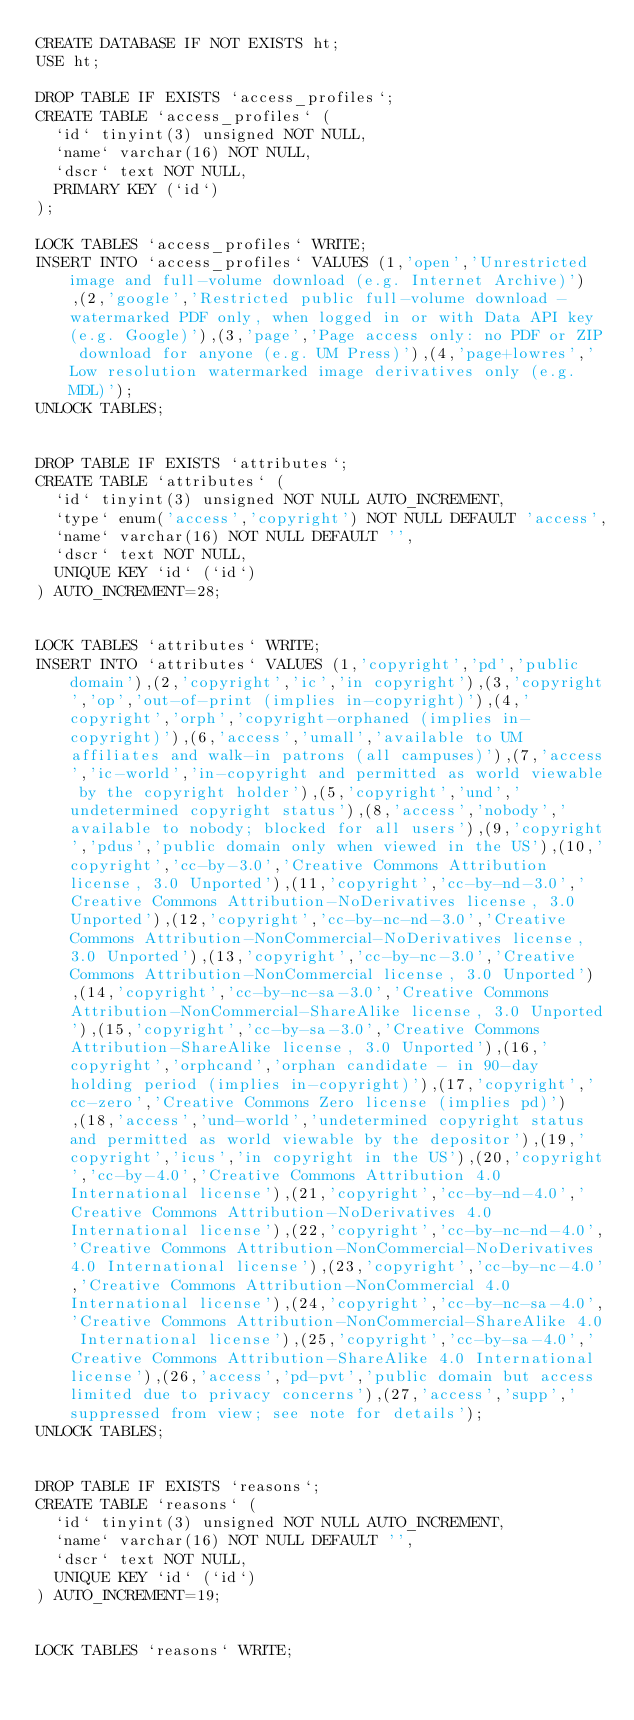Convert code to text. <code><loc_0><loc_0><loc_500><loc_500><_SQL_>CREATE DATABASE IF NOT EXISTS ht;
USE ht;

DROP TABLE IF EXISTS `access_profiles`;
CREATE TABLE `access_profiles` (
  `id` tinyint(3) unsigned NOT NULL,
  `name` varchar(16) NOT NULL,
  `dscr` text NOT NULL,
  PRIMARY KEY (`id`)
);

LOCK TABLES `access_profiles` WRITE;
INSERT INTO `access_profiles` VALUES (1,'open','Unrestricted image and full-volume download (e.g. Internet Archive)'),(2,'google','Restricted public full-volume download - watermarked PDF only, when logged in or with Data API key (e.g. Google)'),(3,'page','Page access only: no PDF or ZIP download for anyone (e.g. UM Press)'),(4,'page+lowres','Low resolution watermarked image derivatives only (e.g. MDL)');
UNLOCK TABLES;


DROP TABLE IF EXISTS `attributes`;
CREATE TABLE `attributes` (
  `id` tinyint(3) unsigned NOT NULL AUTO_INCREMENT,
  `type` enum('access','copyright') NOT NULL DEFAULT 'access',
  `name` varchar(16) NOT NULL DEFAULT '',
  `dscr` text NOT NULL,
  UNIQUE KEY `id` (`id`)
) AUTO_INCREMENT=28;


LOCK TABLES `attributes` WRITE;
INSERT INTO `attributes` VALUES (1,'copyright','pd','public domain'),(2,'copyright','ic','in copyright'),(3,'copyright','op','out-of-print (implies in-copyright)'),(4,'copyright','orph','copyright-orphaned (implies in-copyright)'),(6,'access','umall','available to UM affiliates and walk-in patrons (all campuses)'),(7,'access','ic-world','in-copyright and permitted as world viewable by the copyright holder'),(5,'copyright','und','undetermined copyright status'),(8,'access','nobody','available to nobody; blocked for all users'),(9,'copyright','pdus','public domain only when viewed in the US'),(10,'copyright','cc-by-3.0','Creative Commons Attribution license, 3.0 Unported'),(11,'copyright','cc-by-nd-3.0','Creative Commons Attribution-NoDerivatives license, 3.0 Unported'),(12,'copyright','cc-by-nc-nd-3.0','Creative Commons Attribution-NonCommercial-NoDerivatives license, 3.0 Unported'),(13,'copyright','cc-by-nc-3.0','Creative Commons Attribution-NonCommercial license, 3.0 Unported'),(14,'copyright','cc-by-nc-sa-3.0','Creative Commons Attribution-NonCommercial-ShareAlike license, 3.0 Unported'),(15,'copyright','cc-by-sa-3.0','Creative Commons Attribution-ShareAlike license, 3.0 Unported'),(16,'copyright','orphcand','orphan candidate - in 90-day holding period (implies in-copyright)'),(17,'copyright','cc-zero','Creative Commons Zero license (implies pd)'),(18,'access','und-world','undetermined copyright status and permitted as world viewable by the depositor'),(19,'copyright','icus','in copyright in the US'),(20,'copyright','cc-by-4.0','Creative Commons Attribution 4.0 International license'),(21,'copyright','cc-by-nd-4.0','Creative Commons Attribution-NoDerivatives 4.0 International license'),(22,'copyright','cc-by-nc-nd-4.0','Creative Commons Attribution-NonCommercial-NoDerivatives 4.0 International license'),(23,'copyright','cc-by-nc-4.0','Creative Commons Attribution-NonCommercial 4.0 International license'),(24,'copyright','cc-by-nc-sa-4.0','Creative Commons Attribution-NonCommercial-ShareAlike 4.0 International license'),(25,'copyright','cc-by-sa-4.0','Creative Commons Attribution-ShareAlike 4.0 International license'),(26,'access','pd-pvt','public domain but access limited due to privacy concerns'),(27,'access','supp','suppressed from view; see note for details');
UNLOCK TABLES;


DROP TABLE IF EXISTS `reasons`;
CREATE TABLE `reasons` (
  `id` tinyint(3) unsigned NOT NULL AUTO_INCREMENT,
  `name` varchar(16) NOT NULL DEFAULT '',
  `dscr` text NOT NULL,
  UNIQUE KEY `id` (`id`)
) AUTO_INCREMENT=19;


LOCK TABLES `reasons` WRITE;</code> 